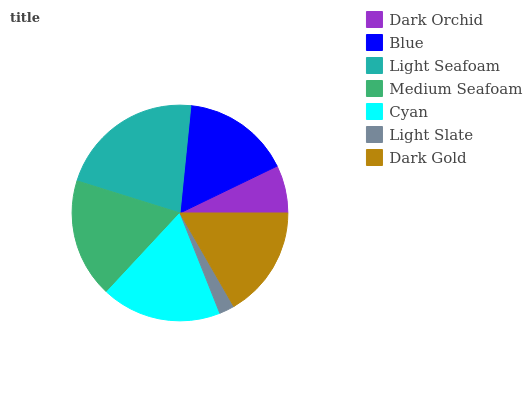Is Light Slate the minimum?
Answer yes or no. Yes. Is Light Seafoam the maximum?
Answer yes or no. Yes. Is Blue the minimum?
Answer yes or no. No. Is Blue the maximum?
Answer yes or no. No. Is Blue greater than Dark Orchid?
Answer yes or no. Yes. Is Dark Orchid less than Blue?
Answer yes or no. Yes. Is Dark Orchid greater than Blue?
Answer yes or no. No. Is Blue less than Dark Orchid?
Answer yes or no. No. Is Dark Gold the high median?
Answer yes or no. Yes. Is Dark Gold the low median?
Answer yes or no. Yes. Is Blue the high median?
Answer yes or no. No. Is Light Seafoam the low median?
Answer yes or no. No. 